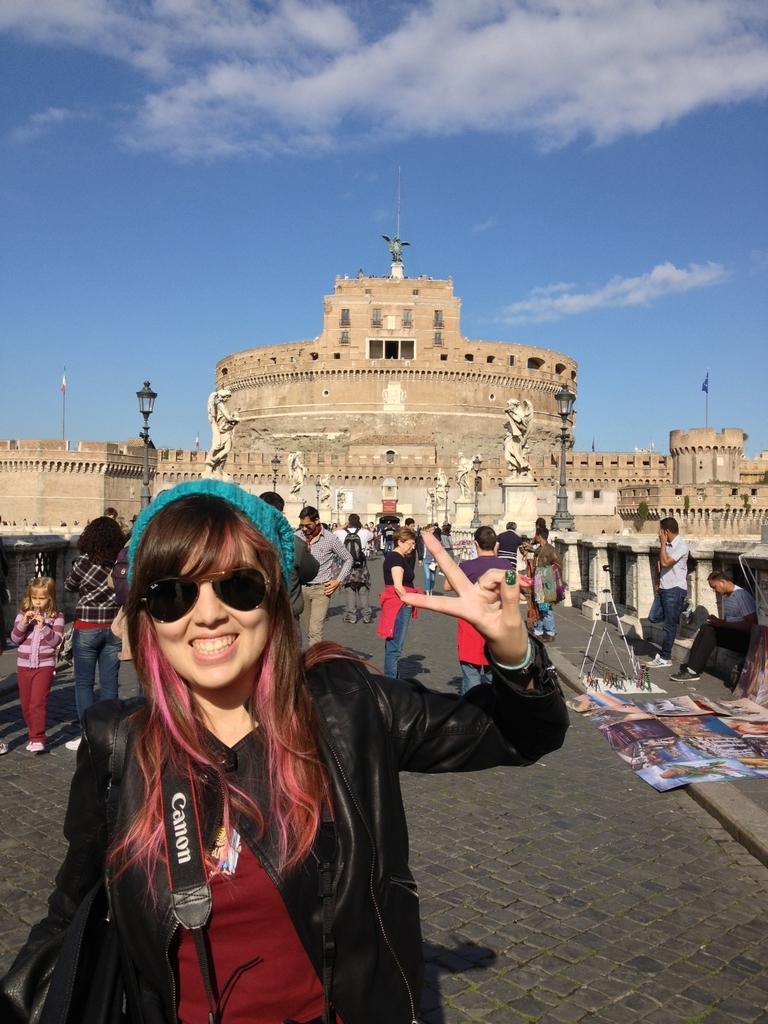In one or two sentences, can you explain what this image depicts? This is the woman standing and smiling. She wore a cap, goggles, jacket and T-shirt. These are the posters, which are kept on the road. Here is a man sitting. This looks like a building. These are the sculptures, which are placed on the pillars. I think these are the street lights. There are groups of people standing. I think this is a flag hanging to the pole. These are the clouds in the sky. 